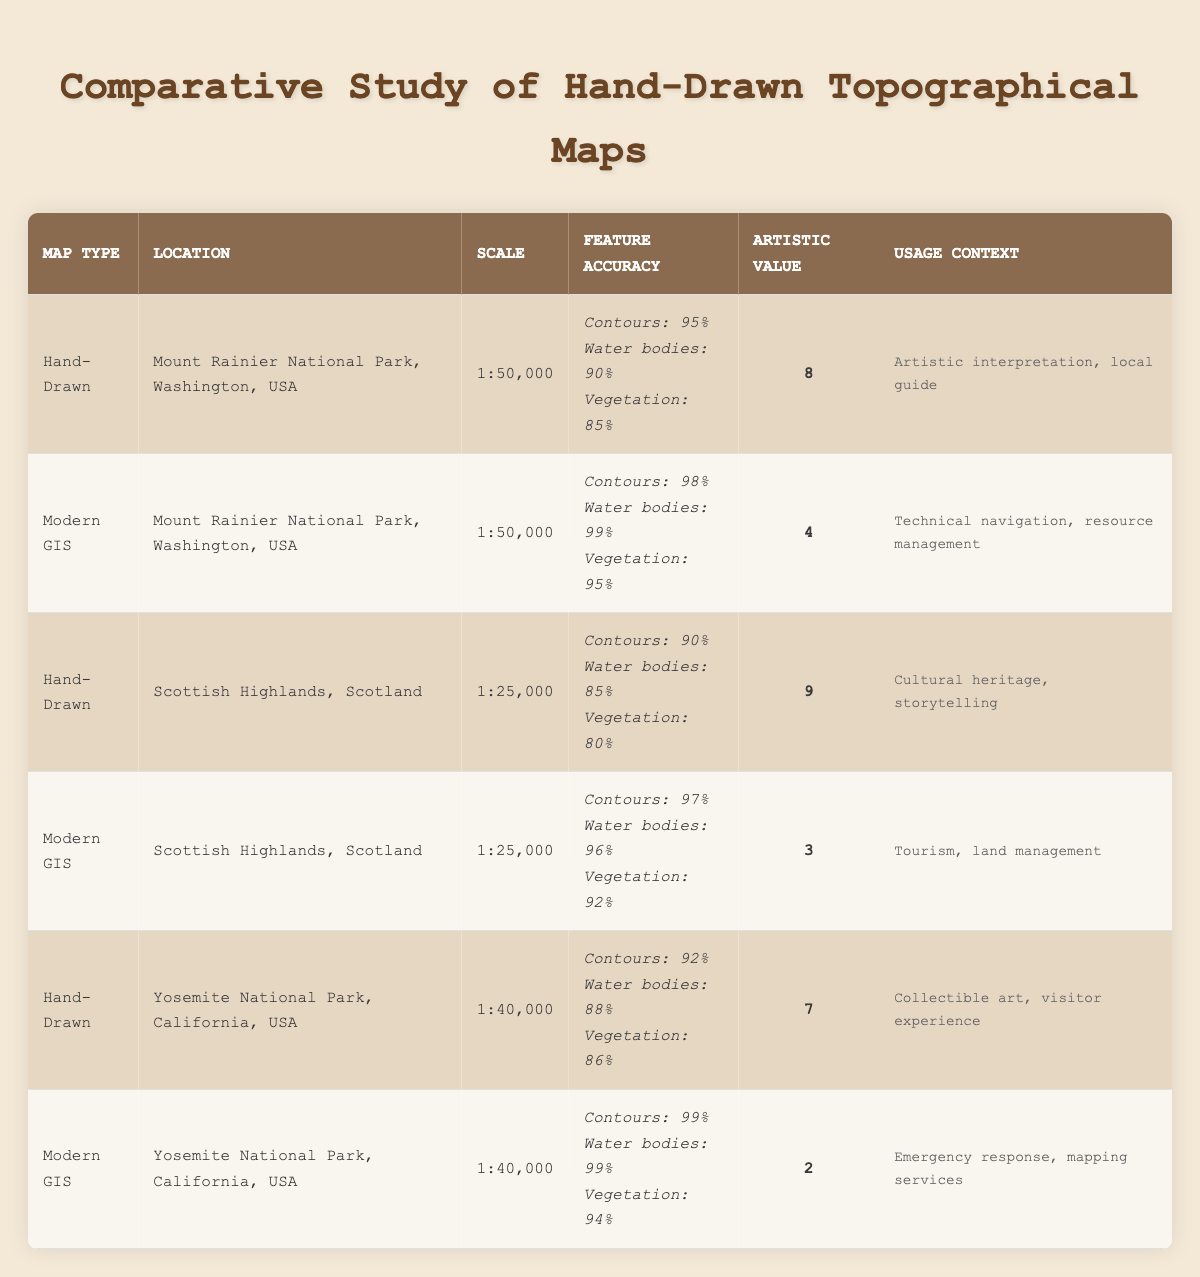What is the artistic value of hand-drawn maps for Mount Rainier National Park? The table shows that the artistic value of hand-drawn maps for Mount Rainier National Park is listed as 8.
Answer: 8 What is the accuracy of water bodies in modern GIS maps for the Scottish Highlands? The table indicates that the accuracy of water bodies in modern GIS maps for the Scottish Highlands is 96%.
Answer: 96% Which map type has higher accuracy for contours in Yosemite National Park? By comparing the contours accuracy for both maps, hand-drawn maps have 92% while modern GIS maps have 99%. Since 99% is greater than 92%, modern GIS maps have higher accuracy.
Answer: Modern GIS What is the average artistic value of hand-drawn maps in this study? The artistic values for hand-drawn maps are 8, 9, and 7. We can calculate the average by adding these values (8 + 9 + 7 = 24) and dividing by 3 (24 / 3 = 8). Therefore, the average artistic value is 8.
Answer: 8 Are modern GIS maps more accurate than hand-drawn maps for vegetation across all locations? Hand-drawn maps have vegetation accuracy of 85%, 80%, and 86%, while modern GIS maps show accuracy of 95%, 92%, and 94%. Since the modern GIS maps consistently have higher values, the statement is true.
Answer: Yes What is the difference in accuracy for contours between the hand-drawn and modern GIS maps in Mount Rainier National Park? Hand-drawn maps have contours accuracy of 95%, while modern GIS maps have 98%. The difference is calculated as 98% - 95% = 3%.
Answer: 3% Which map type is primarily used for artistic interpretation and local guide for Mount Rainier? Referring to the table, the hand-drawn map for Mount Rainier is specified for artistic interpretation and local guide.
Answer: Hand-Drawn In which study location do hand-drawn maps have the lowest accuracy for vegetation? The table shows that, in the Scottish Highlands, hand-drawn maps have a vegetation accuracy of 80%, which is the lowest among the locations studied for hand-drawn maps.
Answer: Scottish Highlands How many more percentage points accurate are modern GIS maps for water bodies compared to hand-drawn maps in Yosemite National Park? The accuracy for water bodies in hand-drawn maps for Yosemite National Park is 88%, and in modern GIS maps, it is 99%. The difference can be calculated as 99% - 88% = 11%.
Answer: 11% 